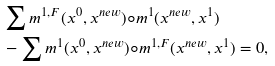<formula> <loc_0><loc_0><loc_500><loc_500>& \sum m ^ { 1 , F } ( x ^ { 0 } , x ^ { n e w } ) \circ m ^ { 1 } ( x ^ { n e w } , x ^ { 1 } ) \\ & - \sum m ^ { 1 } ( x ^ { 0 } , x ^ { n e w } ) \circ m ^ { 1 , F } ( x ^ { n e w } , x ^ { 1 } ) = 0 ,</formula> 